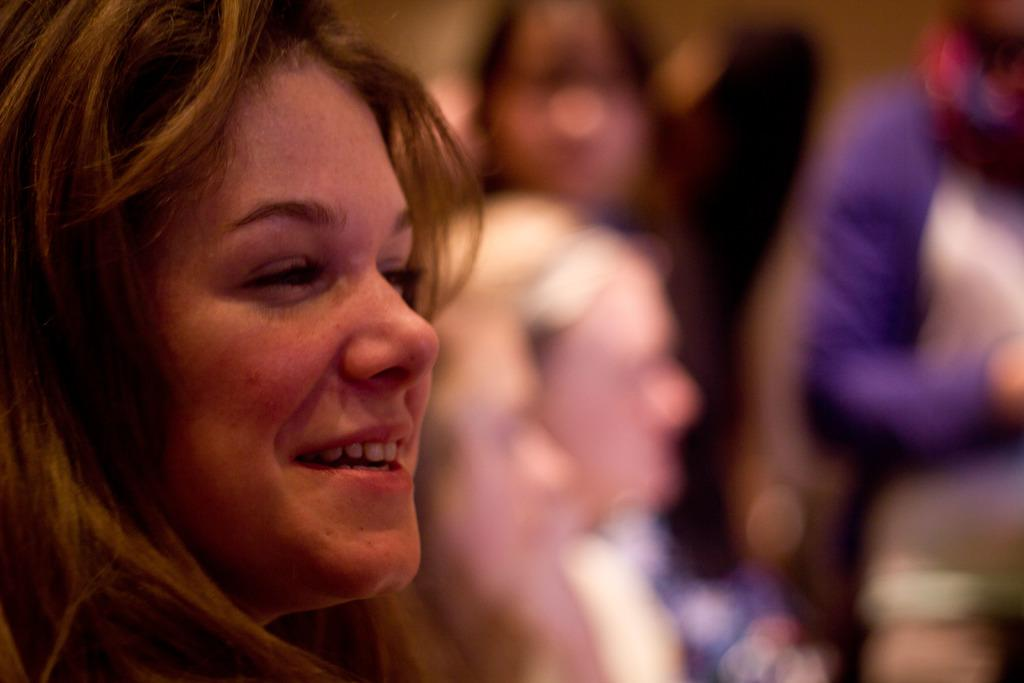Who is present in the image? There is a woman in the image. What is the woman doing in the image? The woman is smiling in the image. Can you describe the surroundings in the image? There are other people in the background of the image. What type of veil is the woman wearing in the image? There is no veil present in the image; the woman is simply smiling. 